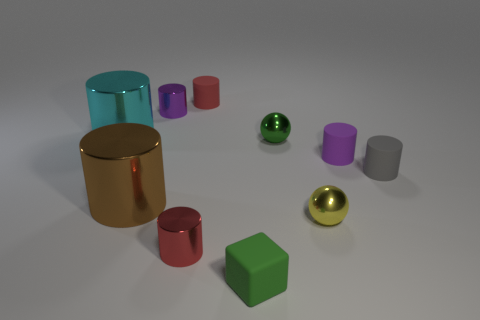Subtract 1 cylinders. How many cylinders are left? 6 Subtract all cyan cylinders. How many cylinders are left? 6 Subtract all cyan shiny cylinders. How many cylinders are left? 6 Subtract all red cylinders. Subtract all yellow spheres. How many cylinders are left? 5 Subtract all spheres. How many objects are left? 8 Subtract 1 green spheres. How many objects are left? 9 Subtract all brown metallic cylinders. Subtract all green metal blocks. How many objects are left? 9 Add 8 brown shiny cylinders. How many brown shiny cylinders are left? 9 Add 3 big gray rubber objects. How many big gray rubber objects exist? 3 